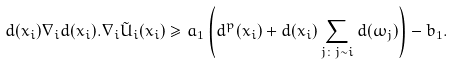<formula> <loc_0><loc_0><loc_500><loc_500>d ( x _ { i } ) \nabla _ { i } d ( x _ { i } ) . \nabla _ { i } \tilde { U } _ { i } ( x _ { i } ) \geq a _ { 1 } \left ( d ^ { p } ( x _ { i } ) + d ( x _ { i } ) \sum _ { j \colon j \sim i } d ( \omega _ { j } ) \right ) - b _ { 1 } .</formula> 